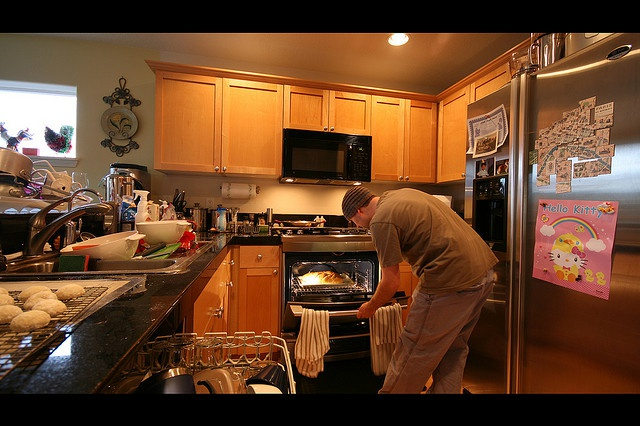Describe the objects in this image and their specific colors. I can see refrigerator in black, maroon, and brown tones, people in black, maroon, and brown tones, oven in black, maroon, brown, and tan tones, microwave in black, maroon, and gray tones, and bowl in black, tan, brown, and maroon tones in this image. 